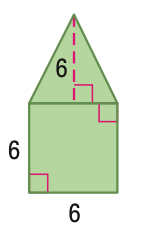Answer the mathemtical geometry problem and directly provide the correct option letter.
Question: Find the area of the figure. Round to the nearest tenth if necessary.
Choices: A: 36 B: 54 C: 72 D: 108 B 